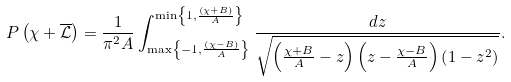Convert formula to latex. <formula><loc_0><loc_0><loc_500><loc_500>P \left ( \chi + \overline { \mathcal { L } } \right ) = \frac { 1 } { \pi ^ { 2 } A } \int _ { \max \left \{ - 1 , \frac { \left ( \chi - B \right ) } { A } \right \} } ^ { \min \left \{ 1 , \frac { \left ( \chi + B \right ) } { A } \right \} } \frac { d z } { \sqrt { \left ( \frac { \chi + B } { A } - z \right ) \left ( z - \frac { \chi - B } { A } \right ) \left ( 1 - z ^ { 2 } \right ) } } .</formula> 